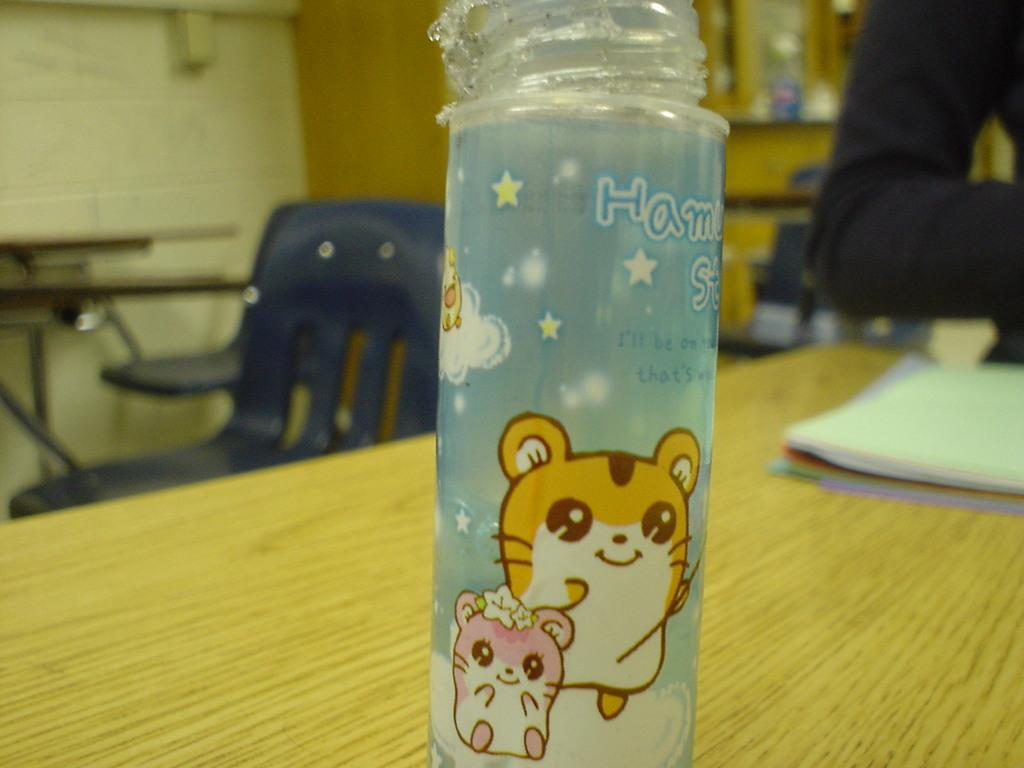What is present on the table in the image? There is a bottle and a book on the table in the image. What can be seen in the background of the image? There is a wall, chairs, and a person in the background of the image. Reasoning: Let' Let's think step by step in order to produce the conversation. We start by identifying the main subject in the image, which is the table. Then, we expand the conversation to include other items that are also visible on the table, such as the bottle and book. Next, we describe the background of the image, mentioning the wall, chairs, and person. Each question is designed to elicit a specific detail about the image that is known from the provided facts. Absurd Question/Answer: What type of seed is being planted by the monkey in the image? There is no monkey or seed present in the image. 